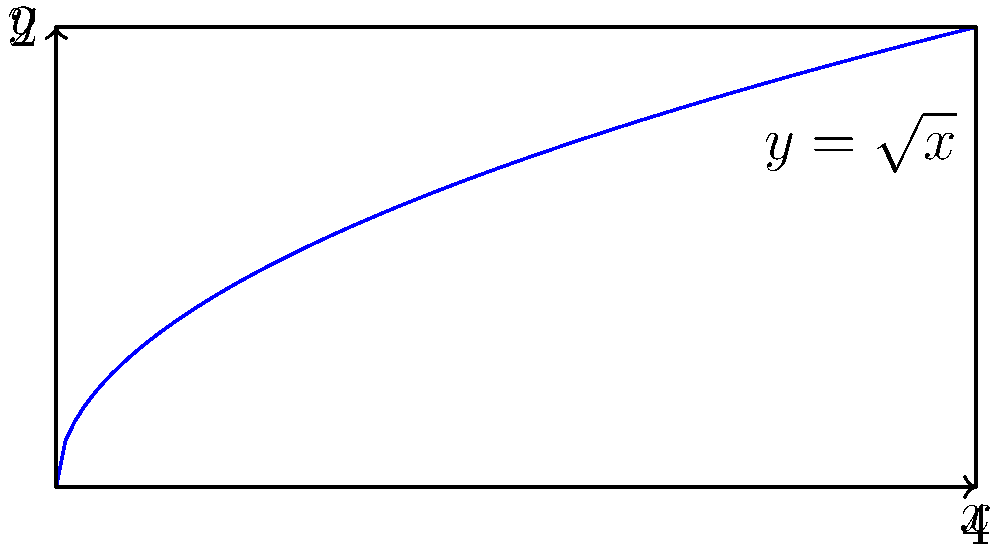In a novel exploring the concept of memory accumulation, a character's memories are represented by the curve $y = \sqrt{x}$ rotated around the y-axis from $x = 0$ to $x = 4$. Calculate the volume of the character's accumulated memories using the shell method. This volume represents the emotional depth and complexity of the character's past experiences. To solve this problem using the shell method, we follow these steps:

1) The shell method formula for volume is:
   $$V = 2\pi \int_a^b x f(x) dx$$
   where $x$ is the radius of each shell and $f(x)$ is the height of the shell.

2) In this case, $f(x) = \sqrt{x}$, $a = 0$, and $b = 4$.

3) Substituting into the formula:
   $$V = 2\pi \int_0^4 x \sqrt{x} dx$$

4) Simplify the integrand:
   $$V = 2\pi \int_0^4 x^{3/2} dx$$

5) Integrate:
   $$V = 2\pi \left[ \frac{2}{5}x^{5/2} \right]_0^4$$

6) Evaluate the definite integral:
   $$V = 2\pi \left( \frac{2}{5}(4)^{5/2} - \frac{2}{5}(0)^{5/2} \right)$$

7) Simplify:
   $$V = 2\pi \cdot \frac{2}{5} \cdot 4^{5/2} = \frac{4\pi}{5} \cdot 32 = \frac{128\pi}{5}$$

8) Therefore, the volume of the character's accumulated memories is $\frac{128\pi}{5}$ cubic units.
Answer: $\frac{128\pi}{5}$ cubic units 